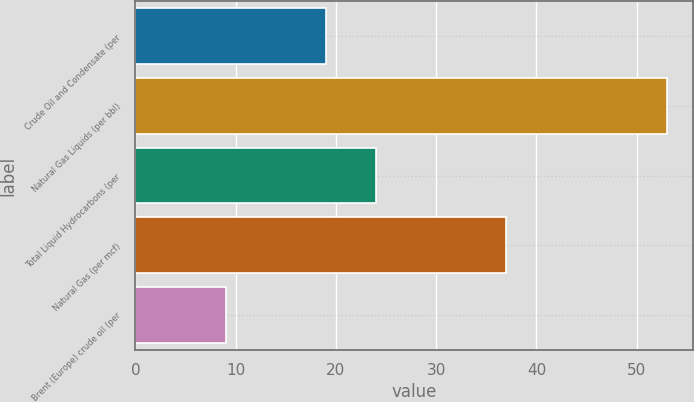Convert chart. <chart><loc_0><loc_0><loc_500><loc_500><bar_chart><fcel>Crude Oil and Condensate (per<fcel>Natural Gas Liquids (per bbl)<fcel>Total Liquid Hydrocarbons (per<fcel>Natural Gas (per mcf)<fcel>Brent (Europe) crude oil (per<nl><fcel>19<fcel>53<fcel>24<fcel>37<fcel>9<nl></chart> 